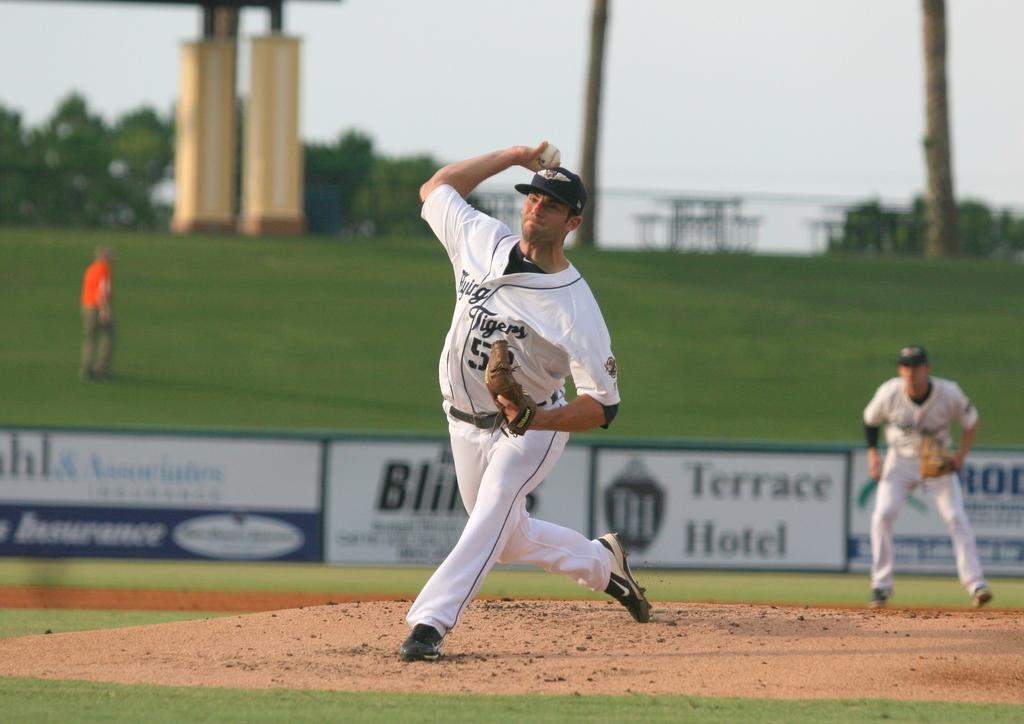<image>
Write a terse but informative summary of the picture. The pitcher for the Tigers winds up to throw the ball. 